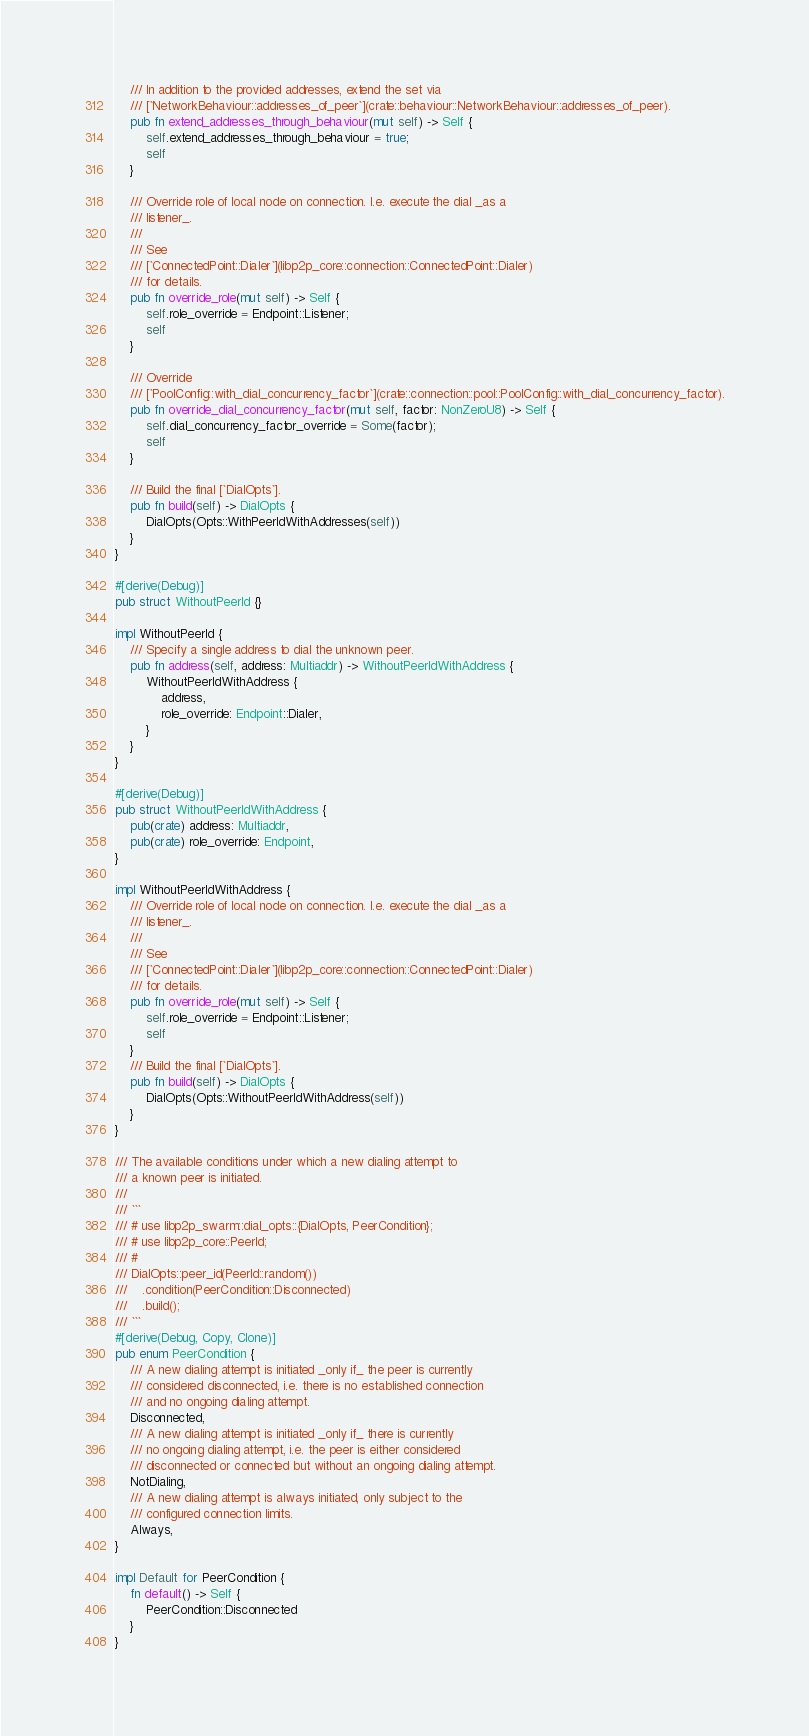Convert code to text. <code><loc_0><loc_0><loc_500><loc_500><_Rust_>    /// In addition to the provided addresses, extend the set via
    /// [`NetworkBehaviour::addresses_of_peer`](crate::behaviour::NetworkBehaviour::addresses_of_peer).
    pub fn extend_addresses_through_behaviour(mut self) -> Self {
        self.extend_addresses_through_behaviour = true;
        self
    }

    /// Override role of local node on connection. I.e. execute the dial _as a
    /// listener_.
    ///
    /// See
    /// [`ConnectedPoint::Dialer`](libp2p_core::connection::ConnectedPoint::Dialer)
    /// for details.
    pub fn override_role(mut self) -> Self {
        self.role_override = Endpoint::Listener;
        self
    }

    /// Override
    /// [`PoolConfig::with_dial_concurrency_factor`](crate::connection::pool::PoolConfig::with_dial_concurrency_factor).
    pub fn override_dial_concurrency_factor(mut self, factor: NonZeroU8) -> Self {
        self.dial_concurrency_factor_override = Some(factor);
        self
    }

    /// Build the final [`DialOpts`].
    pub fn build(self) -> DialOpts {
        DialOpts(Opts::WithPeerIdWithAddresses(self))
    }
}

#[derive(Debug)]
pub struct WithoutPeerId {}

impl WithoutPeerId {
    /// Specify a single address to dial the unknown peer.
    pub fn address(self, address: Multiaddr) -> WithoutPeerIdWithAddress {
        WithoutPeerIdWithAddress {
            address,
            role_override: Endpoint::Dialer,
        }
    }
}

#[derive(Debug)]
pub struct WithoutPeerIdWithAddress {
    pub(crate) address: Multiaddr,
    pub(crate) role_override: Endpoint,
}

impl WithoutPeerIdWithAddress {
    /// Override role of local node on connection. I.e. execute the dial _as a
    /// listener_.
    ///
    /// See
    /// [`ConnectedPoint::Dialer`](libp2p_core::connection::ConnectedPoint::Dialer)
    /// for details.
    pub fn override_role(mut self) -> Self {
        self.role_override = Endpoint::Listener;
        self
    }
    /// Build the final [`DialOpts`].
    pub fn build(self) -> DialOpts {
        DialOpts(Opts::WithoutPeerIdWithAddress(self))
    }
}

/// The available conditions under which a new dialing attempt to
/// a known peer is initiated.
///
/// ```
/// # use libp2p_swarm::dial_opts::{DialOpts, PeerCondition};
/// # use libp2p_core::PeerId;
/// #
/// DialOpts::peer_id(PeerId::random())
///    .condition(PeerCondition::Disconnected)
///    .build();
/// ```
#[derive(Debug, Copy, Clone)]
pub enum PeerCondition {
    /// A new dialing attempt is initiated _only if_ the peer is currently
    /// considered disconnected, i.e. there is no established connection
    /// and no ongoing dialing attempt.
    Disconnected,
    /// A new dialing attempt is initiated _only if_ there is currently
    /// no ongoing dialing attempt, i.e. the peer is either considered
    /// disconnected or connected but without an ongoing dialing attempt.
    NotDialing,
    /// A new dialing attempt is always initiated, only subject to the
    /// configured connection limits.
    Always,
}

impl Default for PeerCondition {
    fn default() -> Self {
        PeerCondition::Disconnected
    }
}
</code> 